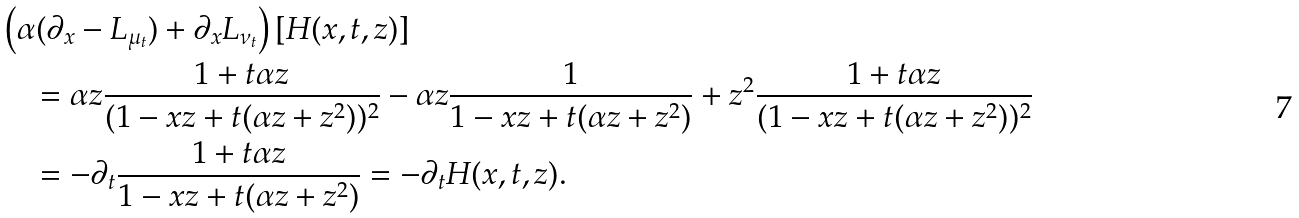Convert formula to latex. <formula><loc_0><loc_0><loc_500><loc_500>& \left ( \alpha ( \partial _ { x } - L _ { \mu _ { t } } ) + \partial _ { x } L _ { \nu _ { t } } \right ) [ H ( x , t , z ) ] \\ & \quad = \alpha z \frac { 1 + t \alpha z } { ( 1 - x z + t ( \alpha z + z ^ { 2 } ) ) ^ { 2 } } - \alpha z \frac { 1 } { 1 - x z + t ( \alpha z + z ^ { 2 } ) } + z ^ { 2 } \frac { 1 + t \alpha z } { ( 1 - x z + t ( \alpha z + z ^ { 2 } ) ) ^ { 2 } } \\ & \quad = - \partial _ { t } \frac { 1 + t \alpha z } { 1 - x z + t ( \alpha z + z ^ { 2 } ) } = - \partial _ { t } H ( x , t , z ) .</formula> 